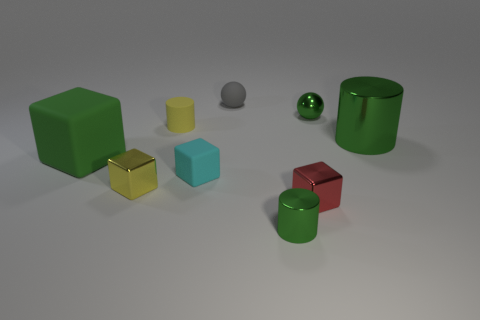What number of other things are there of the same size as the yellow block?
Ensure brevity in your answer.  6. What is the size of the yellow shiny object that is the same shape as the red object?
Provide a succinct answer. Small. What is the shape of the small green object that is behind the large cube?
Your answer should be compact. Sphere. There is a small metal block on the right side of the metal cylinder in front of the cyan block; what color is it?
Offer a terse response. Red. What number of things are either small green metal things in front of the tiny yellow matte thing or green rubber blocks?
Offer a terse response. 2. Do the gray rubber sphere and the shiny object that is to the right of the tiny metal sphere have the same size?
Your answer should be compact. No. How many large things are blue metallic cylinders or green cubes?
Your answer should be very brief. 1. The yellow shiny object has what shape?
Provide a succinct answer. Cube. There is another cylinder that is the same color as the large metallic cylinder; what size is it?
Give a very brief answer. Small. Is there a big yellow sphere made of the same material as the tiny gray thing?
Ensure brevity in your answer.  No. 